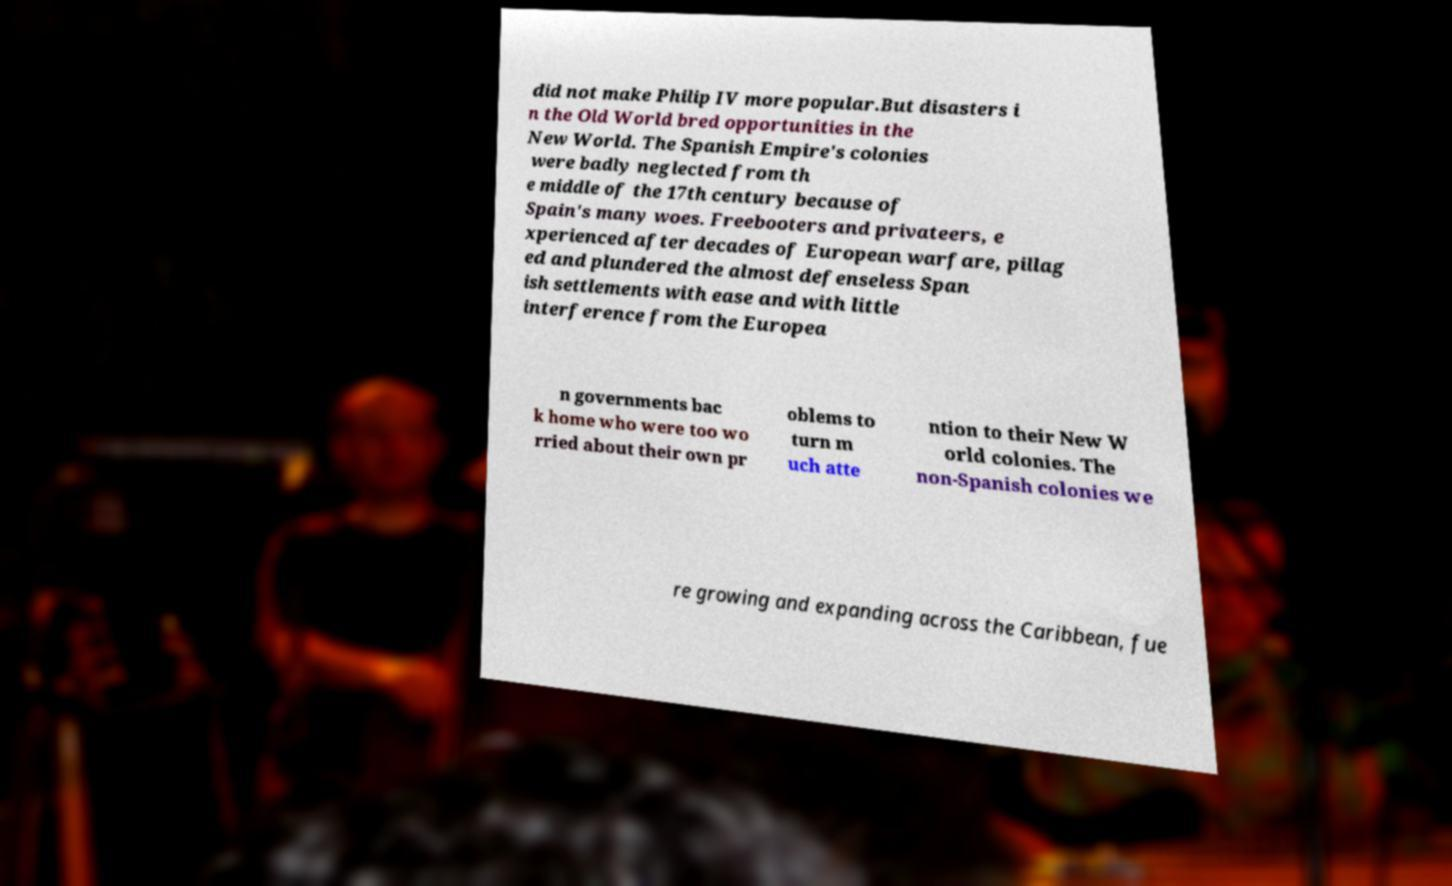What messages or text are displayed in this image? I need them in a readable, typed format. did not make Philip IV more popular.But disasters i n the Old World bred opportunities in the New World. The Spanish Empire's colonies were badly neglected from th e middle of the 17th century because of Spain's many woes. Freebooters and privateers, e xperienced after decades of European warfare, pillag ed and plundered the almost defenseless Span ish settlements with ease and with little interference from the Europea n governments bac k home who were too wo rried about their own pr oblems to turn m uch atte ntion to their New W orld colonies. The non-Spanish colonies we re growing and expanding across the Caribbean, fue 